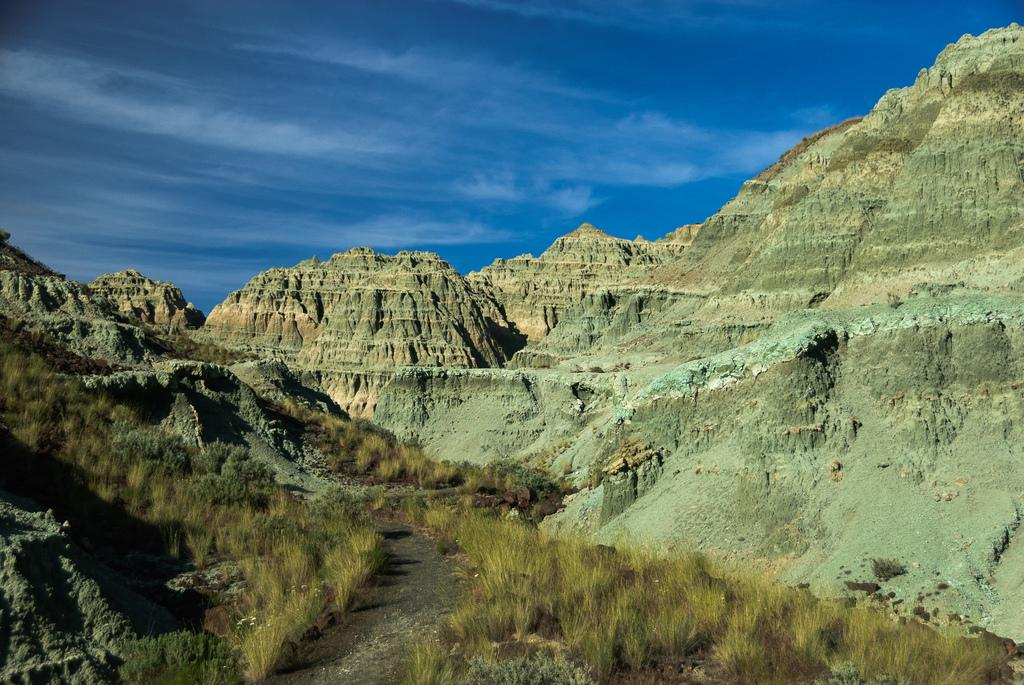What type of path can be seen in the image? There is a small road in the image. What type of vegetation is present on the ground in the image? There are grasses on the ground in the image. What can be seen in the distance in the image? There are hills visible in the background of the image. What is visible above the hills in the image? The sky is visible in the background of the image. What type of instrument is being played by the vein in the image? There is no instrument or vein present in the image. 